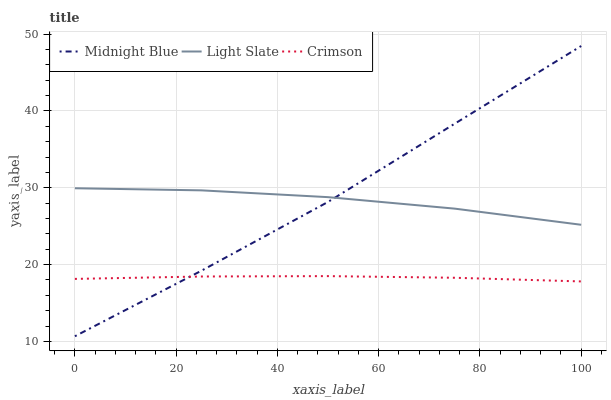Does Crimson have the minimum area under the curve?
Answer yes or no. Yes. Does Midnight Blue have the maximum area under the curve?
Answer yes or no. Yes. Does Midnight Blue have the minimum area under the curve?
Answer yes or no. No. Does Crimson have the maximum area under the curve?
Answer yes or no. No. Is Crimson the smoothest?
Answer yes or no. Yes. Is Light Slate the roughest?
Answer yes or no. Yes. Is Midnight Blue the smoothest?
Answer yes or no. No. Is Midnight Blue the roughest?
Answer yes or no. No. Does Midnight Blue have the lowest value?
Answer yes or no. Yes. Does Crimson have the lowest value?
Answer yes or no. No. Does Midnight Blue have the highest value?
Answer yes or no. Yes. Does Crimson have the highest value?
Answer yes or no. No. Is Crimson less than Light Slate?
Answer yes or no. Yes. Is Light Slate greater than Crimson?
Answer yes or no. Yes. Does Midnight Blue intersect Crimson?
Answer yes or no. Yes. Is Midnight Blue less than Crimson?
Answer yes or no. No. Is Midnight Blue greater than Crimson?
Answer yes or no. No. Does Crimson intersect Light Slate?
Answer yes or no. No. 